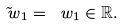Convert formula to latex. <formula><loc_0><loc_0><loc_500><loc_500>\tilde { \ w } _ { 1 } = \ w _ { 1 } \in \mathbb { R } .</formula> 